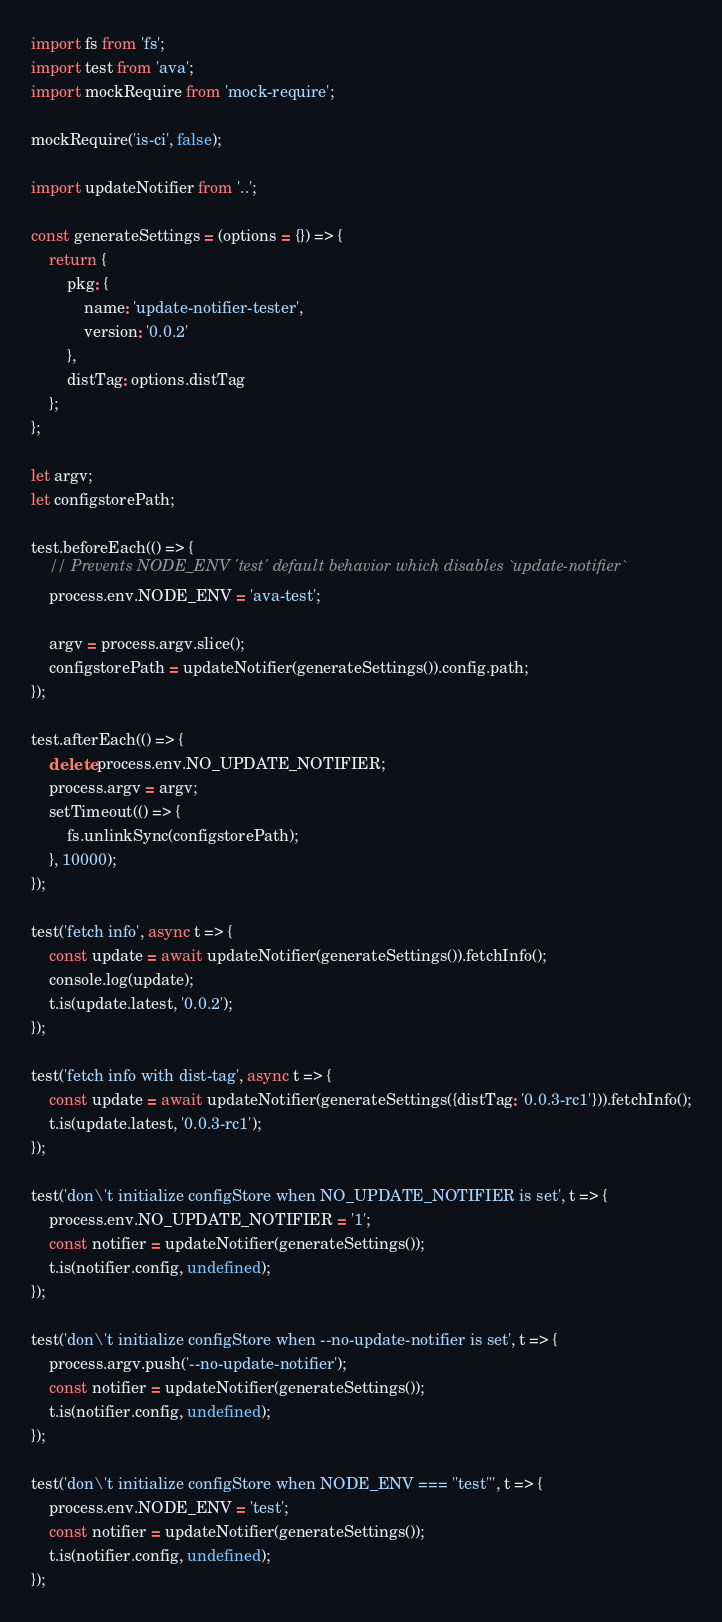Convert code to text. <code><loc_0><loc_0><loc_500><loc_500><_JavaScript_>import fs from 'fs';
import test from 'ava';
import mockRequire from 'mock-require';

mockRequire('is-ci', false);

import updateNotifier from '..';

const generateSettings = (options = {}) => {
	return {
		pkg: {
			name: 'update-notifier-tester',
			version: '0.0.2'
		},
		distTag: options.distTag
	};
};

let argv;
let configstorePath;

test.beforeEach(() => {
	// Prevents NODE_ENV 'test' default behavior which disables `update-notifier`
	process.env.NODE_ENV = 'ava-test';

	argv = process.argv.slice();
	configstorePath = updateNotifier(generateSettings()).config.path;
});

test.afterEach(() => {
	delete process.env.NO_UPDATE_NOTIFIER;
	process.argv = argv;
	setTimeout(() => {
		fs.unlinkSync(configstorePath);
	}, 10000);
});

test('fetch info', async t => {
	const update = await updateNotifier(generateSettings()).fetchInfo();
	console.log(update);
	t.is(update.latest, '0.0.2');
});

test('fetch info with dist-tag', async t => {
	const update = await updateNotifier(generateSettings({distTag: '0.0.3-rc1'})).fetchInfo();
	t.is(update.latest, '0.0.3-rc1');
});

test('don\'t initialize configStore when NO_UPDATE_NOTIFIER is set', t => {
	process.env.NO_UPDATE_NOTIFIER = '1';
	const notifier = updateNotifier(generateSettings());
	t.is(notifier.config, undefined);
});

test('don\'t initialize configStore when --no-update-notifier is set', t => {
	process.argv.push('--no-update-notifier');
	const notifier = updateNotifier(generateSettings());
	t.is(notifier.config, undefined);
});

test('don\'t initialize configStore when NODE_ENV === "test"', t => {
	process.env.NODE_ENV = 'test';
	const notifier = updateNotifier(generateSettings());
	t.is(notifier.config, undefined);
});
</code> 